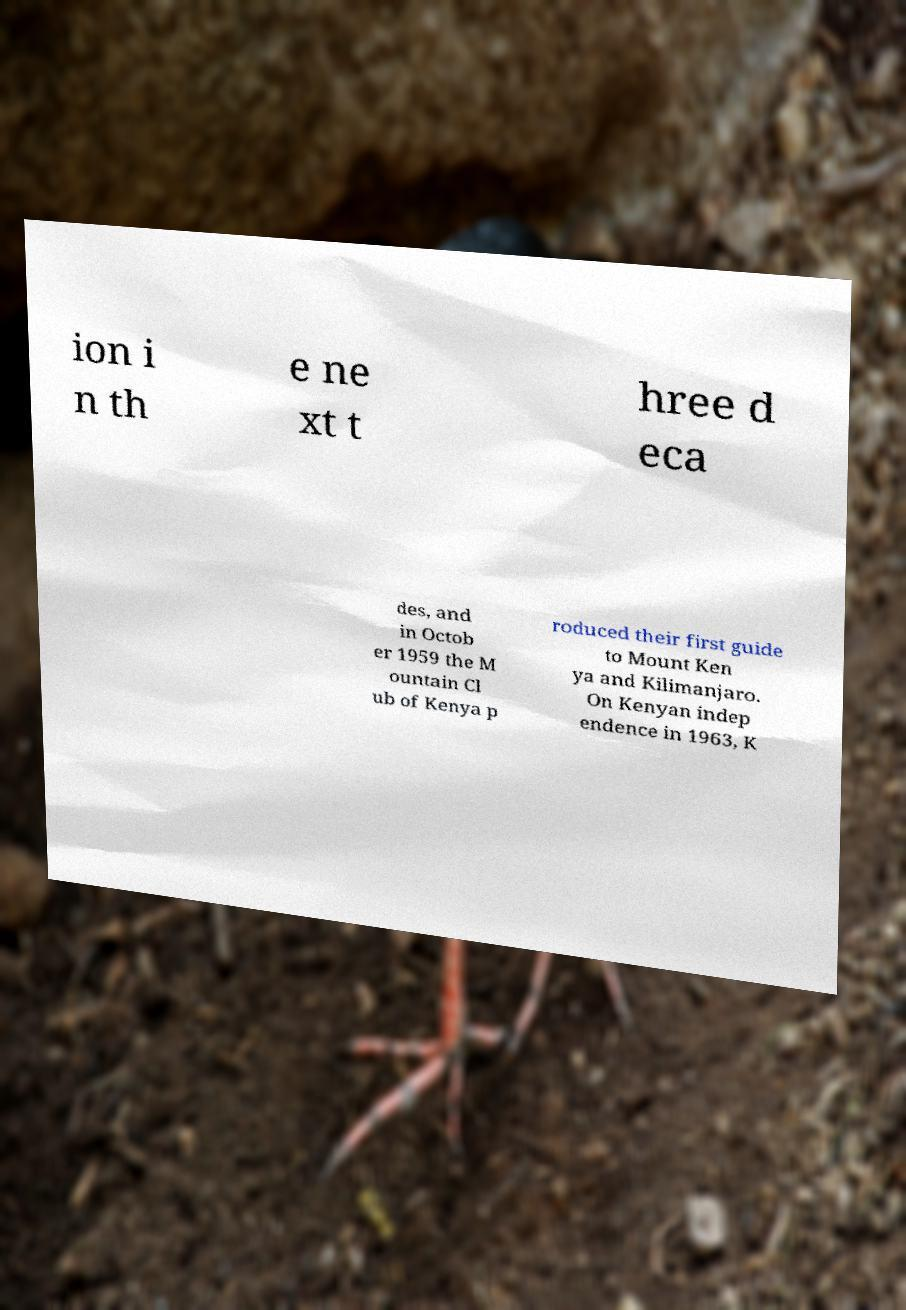For documentation purposes, I need the text within this image transcribed. Could you provide that? ion i n th e ne xt t hree d eca des, and in Octob er 1959 the M ountain Cl ub of Kenya p roduced their first guide to Mount Ken ya and Kilimanjaro. On Kenyan indep endence in 1963, K 